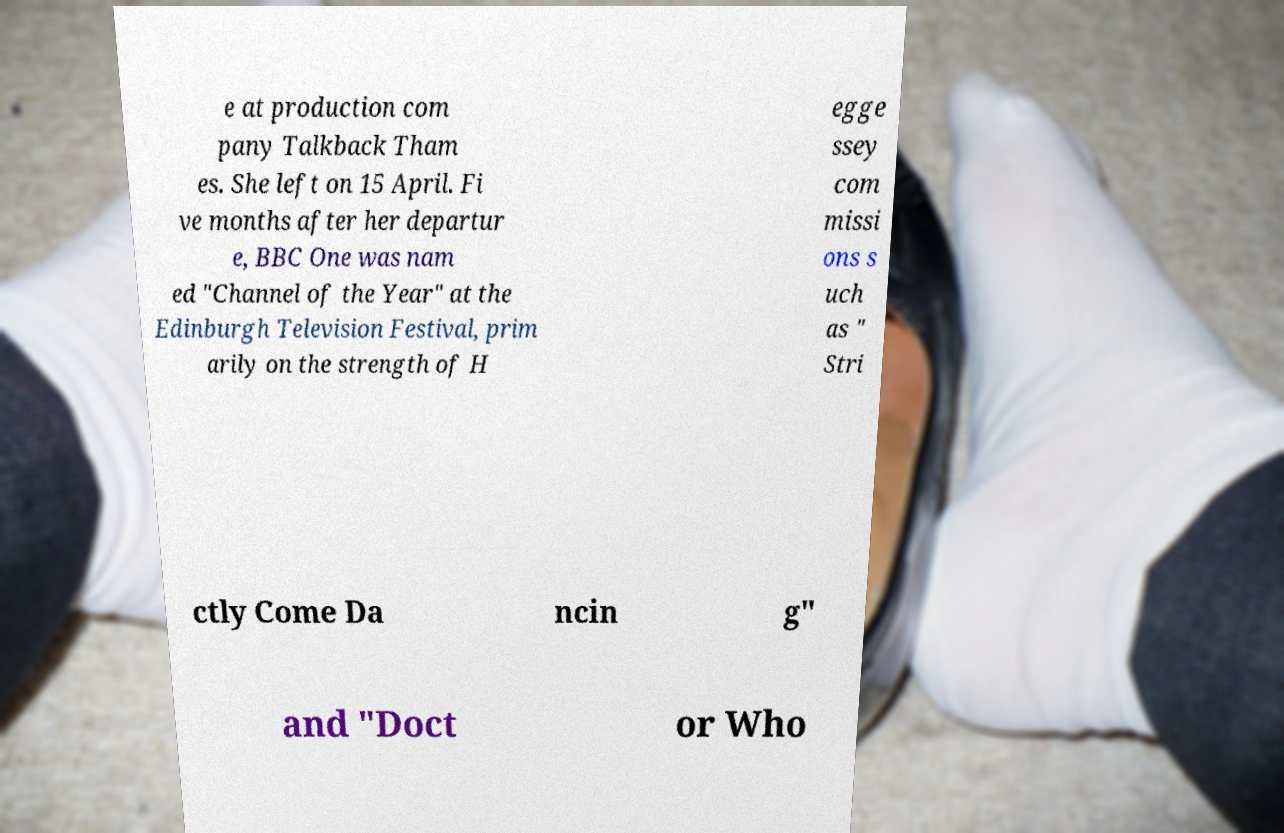There's text embedded in this image that I need extracted. Can you transcribe it verbatim? e at production com pany Talkback Tham es. She left on 15 April. Fi ve months after her departur e, BBC One was nam ed "Channel of the Year" at the Edinburgh Television Festival, prim arily on the strength of H egge ssey com missi ons s uch as " Stri ctly Come Da ncin g" and "Doct or Who 